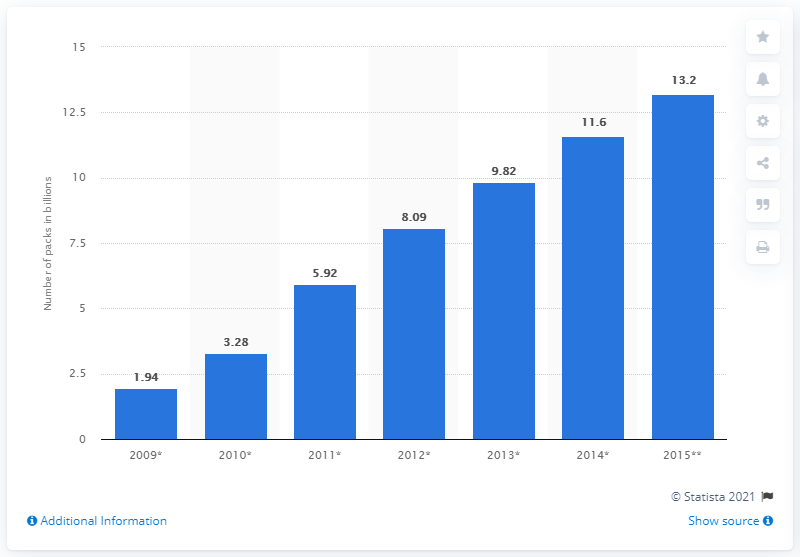List a handful of essential elements in this visual. In 2013, Keurig Green Mountain sold 9,820 single-cup portion packs. 